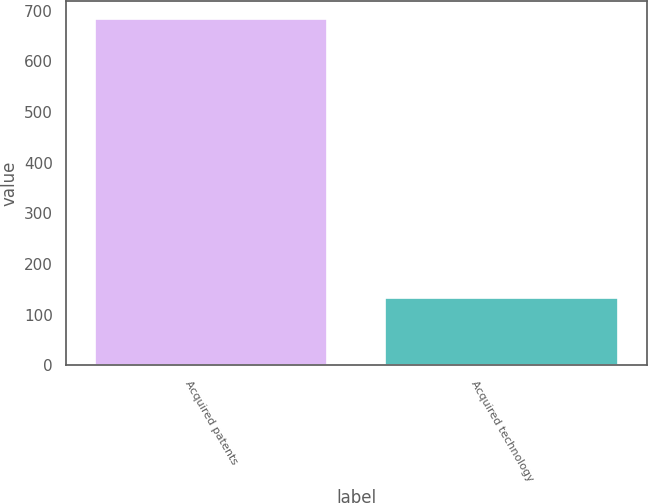Convert chart. <chart><loc_0><loc_0><loc_500><loc_500><bar_chart><fcel>Acquired patents<fcel>Acquired technology<nl><fcel>684<fcel>133<nl></chart> 